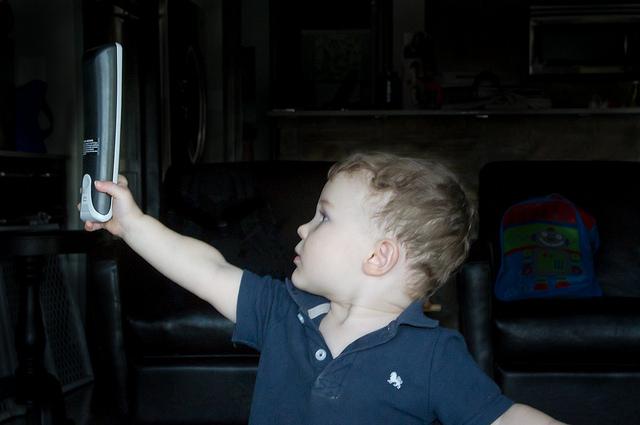How many children are there?
Give a very brief answer. 1. How many children are present?
Quick response, please. 1. What door could he be opening?
Write a very short answer. Garage. What sport is he virtually playing?
Be succinct. None. What color is he?
Short answer required. White. What is the person holding?
Answer briefly. Remote. What game are these children playing?
Quick response, please. Wii. What is the boy holding?
Quick response, please. Remote. Is this image a desperate attempt at art?
Keep it brief. No. What is the baby holding?
Answer briefly. Remote. Is his mouth open?
Answer briefly. No. What is the boy holding on his shoulders?
Quick response, please. Nothing. Is this a teacher?
Concise answer only. No. What is he holding?
Concise answer only. Remote. Is there a laptop?
Give a very brief answer. No. Is there someone wearing glasses?
Be succinct. No. What gender is this child?
Concise answer only. Male. What color is the child's hair?
Keep it brief. Brown. How many people are in the photo?
Short answer required. 1. What hand(s) can be seen?
Quick response, please. Right. 